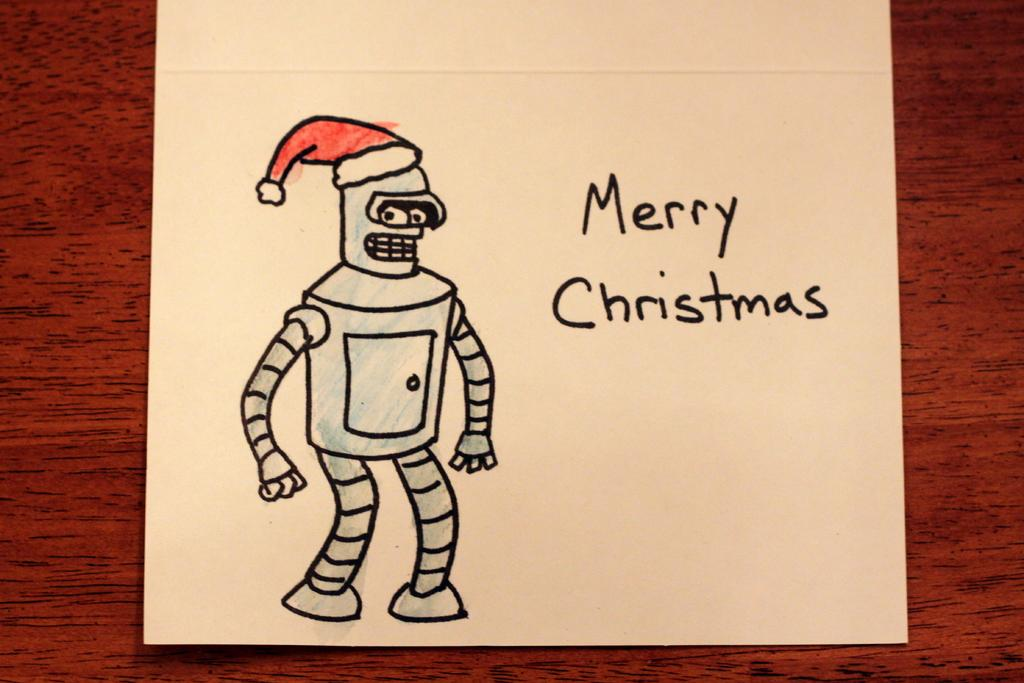What is present on the paper in the image? There is a drawing of a robot on the paper. Where is the paper located in the image? The paper is on an object. Can you describe the drawing on the paper? The drawing on the paper is of a robot. What type of sign is the father holding in the image? There is no father or sign present in the image; it only features a paper with a drawing of a robot. 